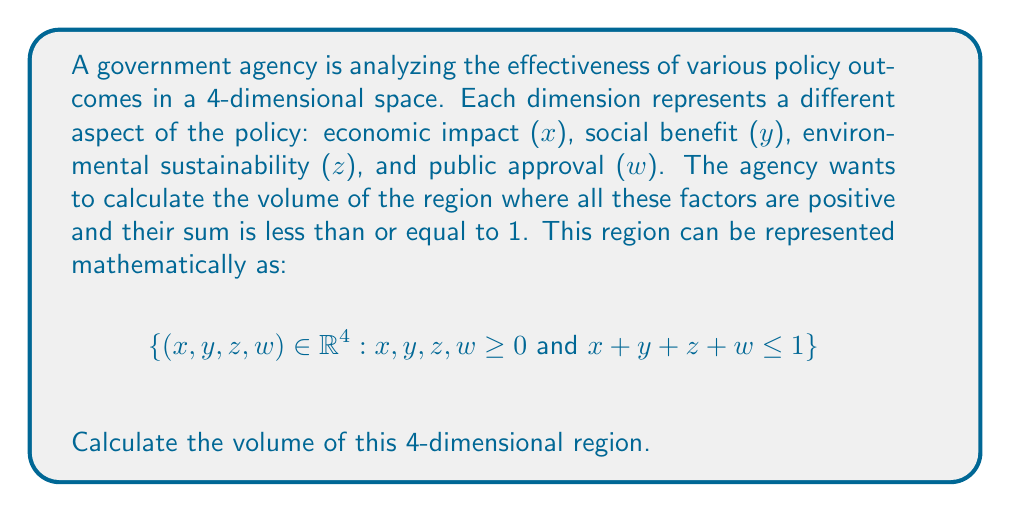Give your solution to this math problem. To solve this problem, we need to use the concept of multiple integrals in higher dimensions. The steps are as follows:

1) The region we're integrating over is a 4-dimensional simplex. In general, the volume of an n-dimensional simplex with side length a is given by:

   $$V_n = \frac{a^n}{n!}$$

2) In our case, n = 4 and a = 1 (since the sum of all coordinates is less than or equal to 1).

3) Substituting these values:

   $$V_4 = \frac{1^4}{4!} = \frac{1}{4!} = \frac{1}{24}$$

4) We can also derive this result using multiple integrals:

   $$V = \int_0^1 \int_0^{1-x} \int_0^{1-x-y} \int_0^{1-x-y-z} dw dz dy dx$$

5) Evaluating from inside out:

   $$\int_0^{1-x-y-z} dw = 1-x-y-z$$

   $$\int_0^{1-x-y} (1-x-y-z) dz = \frac{(1-x-y)^2}{2}$$

   $$\int_0^{1-x} \frac{(1-x-y)^2}{2} dy = \frac{(1-x)^3}{6}$$

   $$\int_0^1 \frac{(1-x)^3}{6} dx = \frac{1}{24}$$

Thus, we arrive at the same result through direct integration.
Answer: $$\frac{1}{24}$$ 